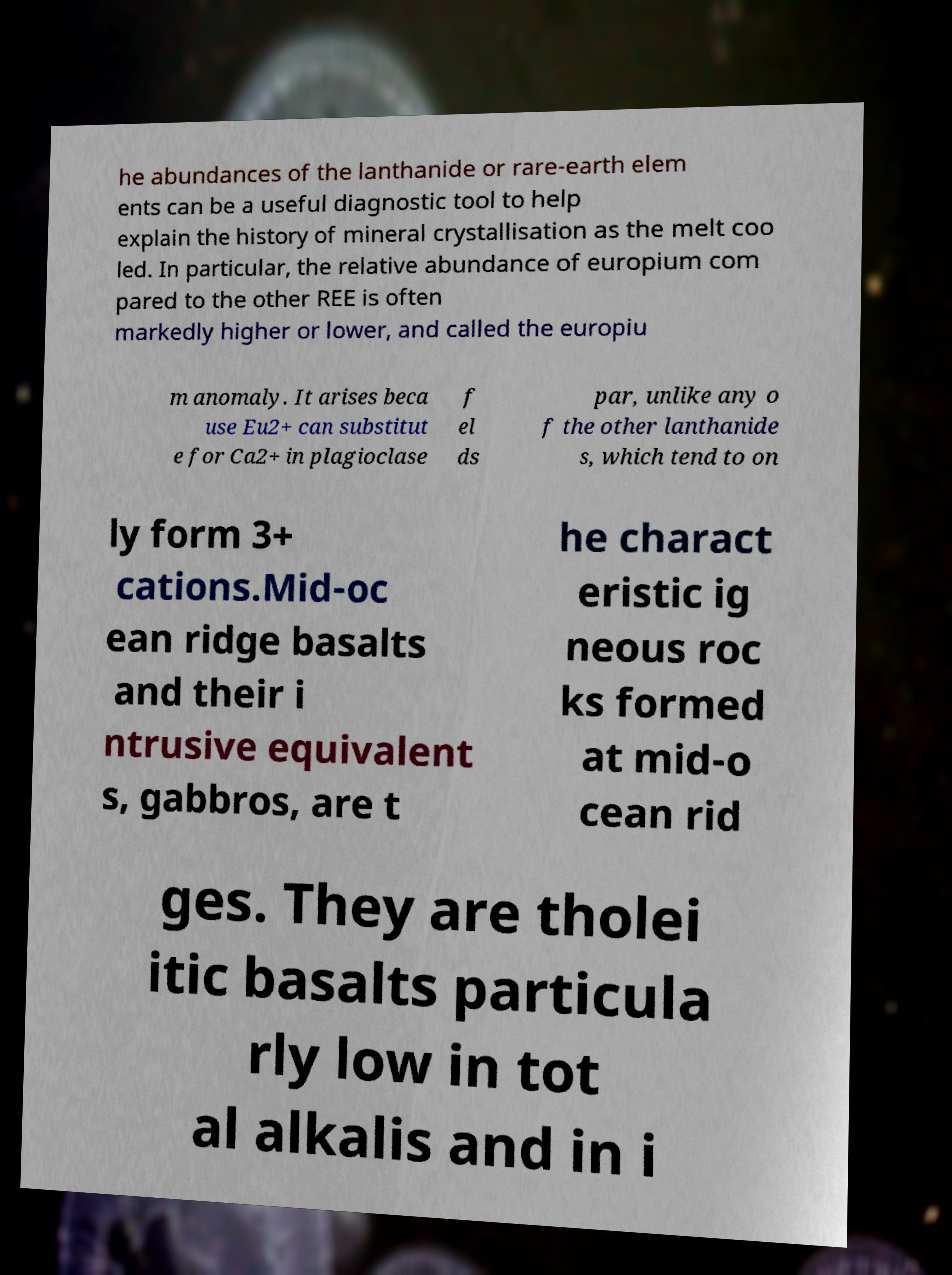Could you extract and type out the text from this image? he abundances of the lanthanide or rare-earth elem ents can be a useful diagnostic tool to help explain the history of mineral crystallisation as the melt coo led. In particular, the relative abundance of europium com pared to the other REE is often markedly higher or lower, and called the europiu m anomaly. It arises beca use Eu2+ can substitut e for Ca2+ in plagioclase f el ds par, unlike any o f the other lanthanide s, which tend to on ly form 3+ cations.Mid-oc ean ridge basalts and their i ntrusive equivalent s, gabbros, are t he charact eristic ig neous roc ks formed at mid-o cean rid ges. They are tholei itic basalts particula rly low in tot al alkalis and in i 